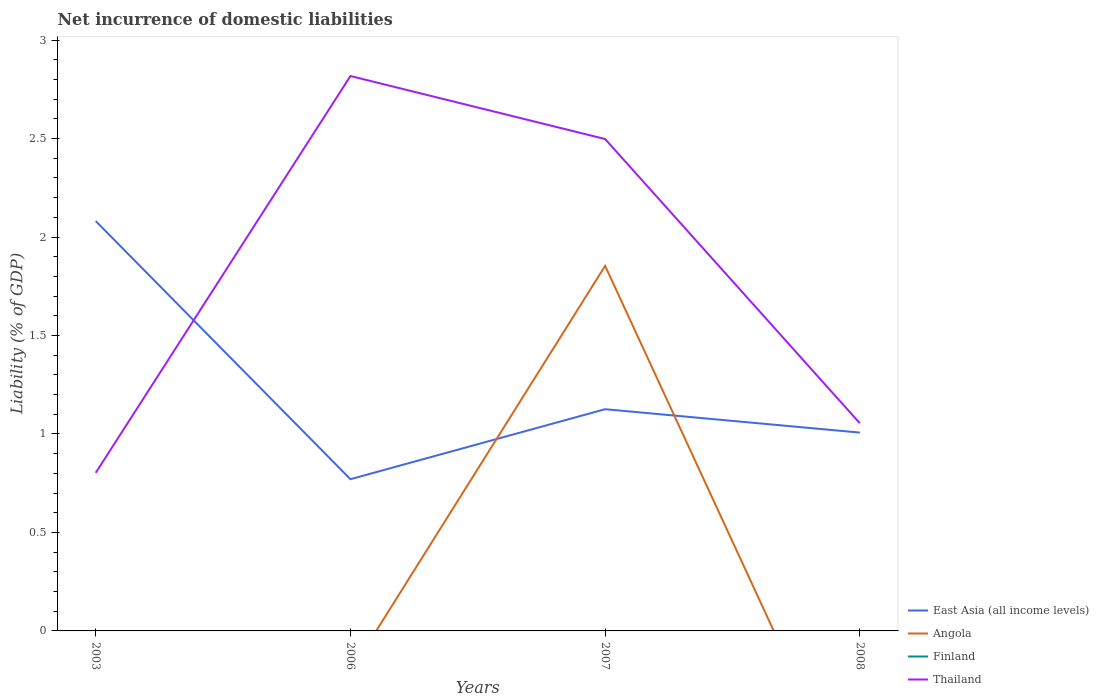How many different coloured lines are there?
Ensure brevity in your answer.  3. Does the line corresponding to Finland intersect with the line corresponding to Angola?
Your answer should be very brief. Yes. Is the number of lines equal to the number of legend labels?
Offer a very short reply. No. Across all years, what is the maximum net incurrence of domestic liabilities in Thailand?
Offer a very short reply. 0.8. What is the total net incurrence of domestic liabilities in Thailand in the graph?
Provide a short and direct response. 0.32. What is the difference between the highest and the second highest net incurrence of domestic liabilities in East Asia (all income levels)?
Keep it short and to the point. 1.31. How many lines are there?
Your response must be concise. 3. How many years are there in the graph?
Provide a succinct answer. 4. Are the values on the major ticks of Y-axis written in scientific E-notation?
Your answer should be very brief. No. Does the graph contain any zero values?
Your answer should be compact. Yes. Does the graph contain grids?
Provide a succinct answer. No. How many legend labels are there?
Offer a terse response. 4. What is the title of the graph?
Keep it short and to the point. Net incurrence of domestic liabilities. Does "Grenada" appear as one of the legend labels in the graph?
Offer a terse response. No. What is the label or title of the Y-axis?
Your answer should be very brief. Liability (% of GDP). What is the Liability (% of GDP) in East Asia (all income levels) in 2003?
Your response must be concise. 2.08. What is the Liability (% of GDP) of Angola in 2003?
Provide a succinct answer. 0. What is the Liability (% of GDP) of Thailand in 2003?
Make the answer very short. 0.8. What is the Liability (% of GDP) of East Asia (all income levels) in 2006?
Your answer should be very brief. 0.77. What is the Liability (% of GDP) in Angola in 2006?
Ensure brevity in your answer.  0. What is the Liability (% of GDP) in Thailand in 2006?
Your answer should be very brief. 2.82. What is the Liability (% of GDP) in East Asia (all income levels) in 2007?
Give a very brief answer. 1.13. What is the Liability (% of GDP) of Angola in 2007?
Your answer should be compact. 1.85. What is the Liability (% of GDP) in Thailand in 2007?
Ensure brevity in your answer.  2.5. What is the Liability (% of GDP) of East Asia (all income levels) in 2008?
Ensure brevity in your answer.  1.01. What is the Liability (% of GDP) in Angola in 2008?
Provide a succinct answer. 0. What is the Liability (% of GDP) of Finland in 2008?
Keep it short and to the point. 0. What is the Liability (% of GDP) of Thailand in 2008?
Give a very brief answer. 1.05. Across all years, what is the maximum Liability (% of GDP) in East Asia (all income levels)?
Make the answer very short. 2.08. Across all years, what is the maximum Liability (% of GDP) in Angola?
Give a very brief answer. 1.85. Across all years, what is the maximum Liability (% of GDP) of Thailand?
Give a very brief answer. 2.82. Across all years, what is the minimum Liability (% of GDP) in East Asia (all income levels)?
Provide a succinct answer. 0.77. Across all years, what is the minimum Liability (% of GDP) in Angola?
Offer a terse response. 0. Across all years, what is the minimum Liability (% of GDP) of Thailand?
Provide a succinct answer. 0.8. What is the total Liability (% of GDP) of East Asia (all income levels) in the graph?
Give a very brief answer. 4.98. What is the total Liability (% of GDP) of Angola in the graph?
Keep it short and to the point. 1.85. What is the total Liability (% of GDP) of Finland in the graph?
Give a very brief answer. 0. What is the total Liability (% of GDP) in Thailand in the graph?
Give a very brief answer. 7.17. What is the difference between the Liability (% of GDP) of East Asia (all income levels) in 2003 and that in 2006?
Keep it short and to the point. 1.31. What is the difference between the Liability (% of GDP) of Thailand in 2003 and that in 2006?
Make the answer very short. -2.02. What is the difference between the Liability (% of GDP) in East Asia (all income levels) in 2003 and that in 2007?
Ensure brevity in your answer.  0.96. What is the difference between the Liability (% of GDP) of Thailand in 2003 and that in 2007?
Your response must be concise. -1.7. What is the difference between the Liability (% of GDP) in East Asia (all income levels) in 2003 and that in 2008?
Keep it short and to the point. 1.07. What is the difference between the Liability (% of GDP) in Thailand in 2003 and that in 2008?
Give a very brief answer. -0.25. What is the difference between the Liability (% of GDP) in East Asia (all income levels) in 2006 and that in 2007?
Your response must be concise. -0.36. What is the difference between the Liability (% of GDP) in Thailand in 2006 and that in 2007?
Provide a succinct answer. 0.32. What is the difference between the Liability (% of GDP) in East Asia (all income levels) in 2006 and that in 2008?
Offer a very short reply. -0.24. What is the difference between the Liability (% of GDP) of Thailand in 2006 and that in 2008?
Provide a short and direct response. 1.76. What is the difference between the Liability (% of GDP) of East Asia (all income levels) in 2007 and that in 2008?
Provide a succinct answer. 0.12. What is the difference between the Liability (% of GDP) in Thailand in 2007 and that in 2008?
Your answer should be very brief. 1.44. What is the difference between the Liability (% of GDP) in East Asia (all income levels) in 2003 and the Liability (% of GDP) in Thailand in 2006?
Your answer should be very brief. -0.74. What is the difference between the Liability (% of GDP) in East Asia (all income levels) in 2003 and the Liability (% of GDP) in Angola in 2007?
Make the answer very short. 0.23. What is the difference between the Liability (% of GDP) of East Asia (all income levels) in 2003 and the Liability (% of GDP) of Thailand in 2007?
Your answer should be compact. -0.42. What is the difference between the Liability (% of GDP) of East Asia (all income levels) in 2003 and the Liability (% of GDP) of Thailand in 2008?
Offer a terse response. 1.03. What is the difference between the Liability (% of GDP) of East Asia (all income levels) in 2006 and the Liability (% of GDP) of Angola in 2007?
Make the answer very short. -1.08. What is the difference between the Liability (% of GDP) in East Asia (all income levels) in 2006 and the Liability (% of GDP) in Thailand in 2007?
Your response must be concise. -1.73. What is the difference between the Liability (% of GDP) in East Asia (all income levels) in 2006 and the Liability (% of GDP) in Thailand in 2008?
Provide a succinct answer. -0.28. What is the difference between the Liability (% of GDP) of East Asia (all income levels) in 2007 and the Liability (% of GDP) of Thailand in 2008?
Offer a terse response. 0.07. What is the difference between the Liability (% of GDP) in Angola in 2007 and the Liability (% of GDP) in Thailand in 2008?
Your response must be concise. 0.8. What is the average Liability (% of GDP) in East Asia (all income levels) per year?
Your answer should be very brief. 1.25. What is the average Liability (% of GDP) of Angola per year?
Provide a short and direct response. 0.46. What is the average Liability (% of GDP) in Finland per year?
Provide a short and direct response. 0. What is the average Liability (% of GDP) of Thailand per year?
Provide a succinct answer. 1.79. In the year 2003, what is the difference between the Liability (% of GDP) in East Asia (all income levels) and Liability (% of GDP) in Thailand?
Ensure brevity in your answer.  1.28. In the year 2006, what is the difference between the Liability (% of GDP) of East Asia (all income levels) and Liability (% of GDP) of Thailand?
Your answer should be very brief. -2.05. In the year 2007, what is the difference between the Liability (% of GDP) in East Asia (all income levels) and Liability (% of GDP) in Angola?
Ensure brevity in your answer.  -0.73. In the year 2007, what is the difference between the Liability (% of GDP) of East Asia (all income levels) and Liability (% of GDP) of Thailand?
Your answer should be compact. -1.37. In the year 2007, what is the difference between the Liability (% of GDP) of Angola and Liability (% of GDP) of Thailand?
Your answer should be compact. -0.64. In the year 2008, what is the difference between the Liability (% of GDP) of East Asia (all income levels) and Liability (% of GDP) of Thailand?
Provide a succinct answer. -0.05. What is the ratio of the Liability (% of GDP) in East Asia (all income levels) in 2003 to that in 2006?
Offer a very short reply. 2.7. What is the ratio of the Liability (% of GDP) in Thailand in 2003 to that in 2006?
Your response must be concise. 0.28. What is the ratio of the Liability (% of GDP) of East Asia (all income levels) in 2003 to that in 2007?
Offer a terse response. 1.85. What is the ratio of the Liability (% of GDP) in Thailand in 2003 to that in 2007?
Make the answer very short. 0.32. What is the ratio of the Liability (% of GDP) in East Asia (all income levels) in 2003 to that in 2008?
Offer a terse response. 2.07. What is the ratio of the Liability (% of GDP) of Thailand in 2003 to that in 2008?
Offer a very short reply. 0.76. What is the ratio of the Liability (% of GDP) of East Asia (all income levels) in 2006 to that in 2007?
Your answer should be compact. 0.68. What is the ratio of the Liability (% of GDP) of Thailand in 2006 to that in 2007?
Ensure brevity in your answer.  1.13. What is the ratio of the Liability (% of GDP) of East Asia (all income levels) in 2006 to that in 2008?
Offer a very short reply. 0.77. What is the ratio of the Liability (% of GDP) in Thailand in 2006 to that in 2008?
Ensure brevity in your answer.  2.67. What is the ratio of the Liability (% of GDP) in East Asia (all income levels) in 2007 to that in 2008?
Make the answer very short. 1.12. What is the ratio of the Liability (% of GDP) in Thailand in 2007 to that in 2008?
Your answer should be very brief. 2.37. What is the difference between the highest and the second highest Liability (% of GDP) of East Asia (all income levels)?
Your answer should be compact. 0.96. What is the difference between the highest and the second highest Liability (% of GDP) in Thailand?
Give a very brief answer. 0.32. What is the difference between the highest and the lowest Liability (% of GDP) in East Asia (all income levels)?
Offer a very short reply. 1.31. What is the difference between the highest and the lowest Liability (% of GDP) of Angola?
Provide a succinct answer. 1.85. What is the difference between the highest and the lowest Liability (% of GDP) in Thailand?
Keep it short and to the point. 2.02. 